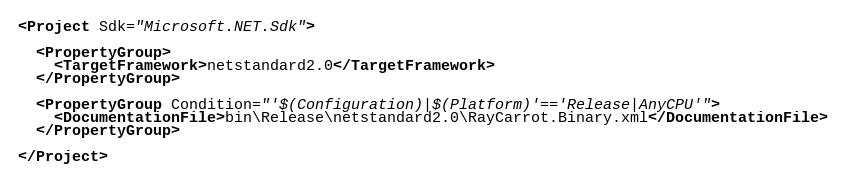<code> <loc_0><loc_0><loc_500><loc_500><_XML_><Project Sdk="Microsoft.NET.Sdk">

  <PropertyGroup>
    <TargetFramework>netstandard2.0</TargetFramework>
  </PropertyGroup>

  <PropertyGroup Condition="'$(Configuration)|$(Platform)'=='Release|AnyCPU'">
    <DocumentationFile>bin\Release\netstandard2.0\RayCarrot.Binary.xml</DocumentationFile>
  </PropertyGroup>

</Project></code> 